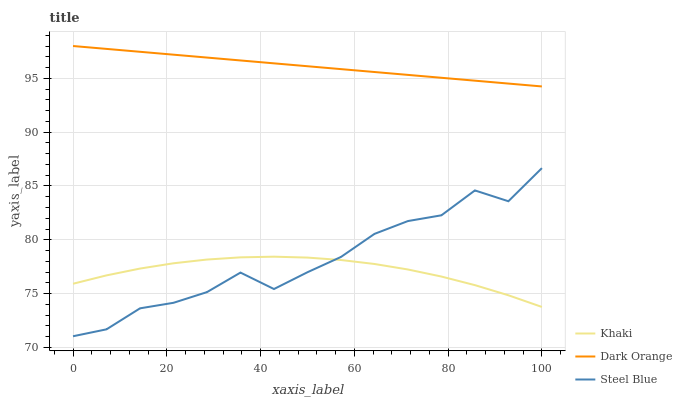Does Khaki have the minimum area under the curve?
Answer yes or no. Yes. Does Dark Orange have the maximum area under the curve?
Answer yes or no. Yes. Does Steel Blue have the minimum area under the curve?
Answer yes or no. No. Does Steel Blue have the maximum area under the curve?
Answer yes or no. No. Is Dark Orange the smoothest?
Answer yes or no. Yes. Is Steel Blue the roughest?
Answer yes or no. Yes. Is Khaki the smoothest?
Answer yes or no. No. Is Khaki the roughest?
Answer yes or no. No. Does Steel Blue have the lowest value?
Answer yes or no. Yes. Does Khaki have the lowest value?
Answer yes or no. No. Does Dark Orange have the highest value?
Answer yes or no. Yes. Does Steel Blue have the highest value?
Answer yes or no. No. Is Khaki less than Dark Orange?
Answer yes or no. Yes. Is Dark Orange greater than Steel Blue?
Answer yes or no. Yes. Does Steel Blue intersect Khaki?
Answer yes or no. Yes. Is Steel Blue less than Khaki?
Answer yes or no. No. Is Steel Blue greater than Khaki?
Answer yes or no. No. Does Khaki intersect Dark Orange?
Answer yes or no. No. 